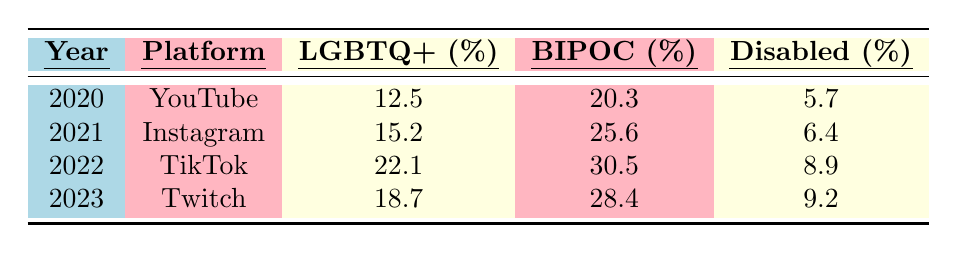What percentage of content came from LGBTQ+ creators on TikTok in 2022? The table shows that in 2022, TikTok has 22.1% of content from LGBTQ+ creators.
Answer: 22.1% Which platform had the highest percentage of content from BIPOC creators? By comparing the BIPOC percentages across platforms, TikTok in 2022 had the highest percentage at 30.5%.
Answer: TikTok in 2022 What was the total percentage of content from Disabled creators across all years in the table? The percentages for Disabled creators are 5.7 (2020) + 6.4 (2021) + 8.9 (2022) + 9.2 (2023) = 30.2%.
Answer: 30.2% Did the percentage of content from LGBTQ+ creators increase from 2020 to 2023? The percentages increased from 12.5% (2020) to 18.7% (2023), which indicates an increase.
Answer: Yes What is the average percentage of content from BIPOC creators over the four years listed? Adding the BIPOC percentages: 20.3 (2020) + 25.6 (2021) + 30.5 (2022) + 28.4 (2023) = 104.8%. Dividing by 4 gives an average of 104.8% / 4 = 26.2%.
Answer: 26.2% Was the percentage of content from Disabled creators consistently below 10% for all years? The percentages for Disabled creators in all years are 5.7%, 6.4%, 8.9%, and 9.2%. Only 9.2% is below 10%, while the other years are also below 10%.
Answer: No Which year exhibited the greatest increase in the percentage of content from LGBTQ+ creators compared to the previous year? The percentage increased from 15.2% (2021) to 22.1% (2022), which is the largest increase of 6.9%.
Answer: 2022 How much more content was produced by BIPOC creators in 2022 compared to 2020? BIPOC creators produced 30.5% in 2022 and 20.3% in 2020. The difference is 30.5% - 20.3% = 10.2%.
Answer: 10.2% What percentage of content from Disabled creators was reported for Instagram in 2021 compared to TikTok in 2022? Instagram in 2021 reported 6.4%, while TikTok in 2022 reported 8.9%. Therefore, TikTok had a higher percentage.
Answer: TikTok in 2022 Did Twitch in 2023 have more content from LGBTQ+ creators or Disabled creators? Twitch reported 18.7% for LGBTQ+ creators and 9.2% for Disabled creators, indicating more content from LGBTQ+ creators.
Answer: LGBTQ+ creators 